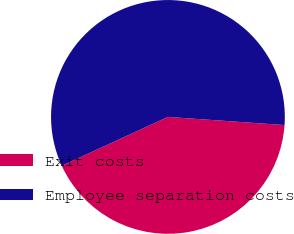<chart> <loc_0><loc_0><loc_500><loc_500><pie_chart><fcel>Exit costs<fcel>Employee separation costs<nl><fcel>42.03%<fcel>57.97%<nl></chart> 